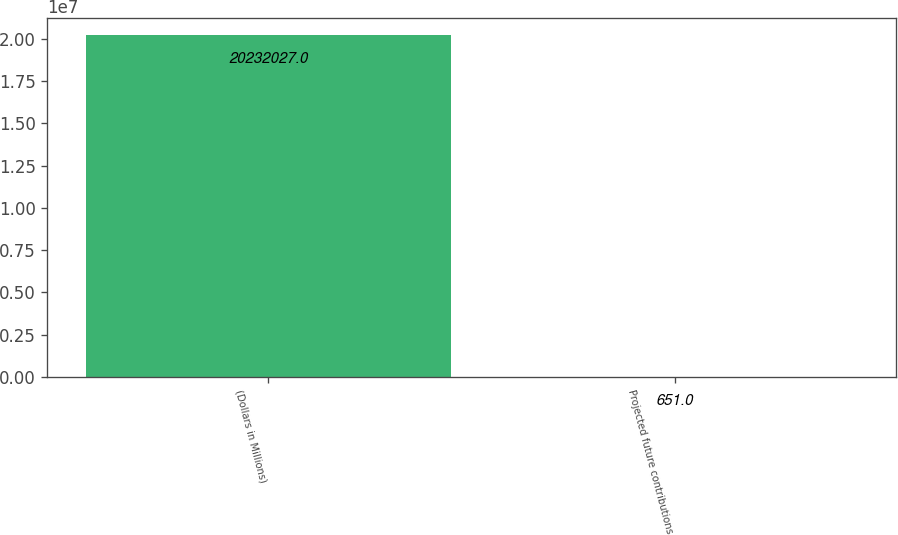Convert chart to OTSL. <chart><loc_0><loc_0><loc_500><loc_500><bar_chart><fcel>(Dollars in Millions)<fcel>Projected future contributions<nl><fcel>2.0232e+07<fcel>651<nl></chart> 